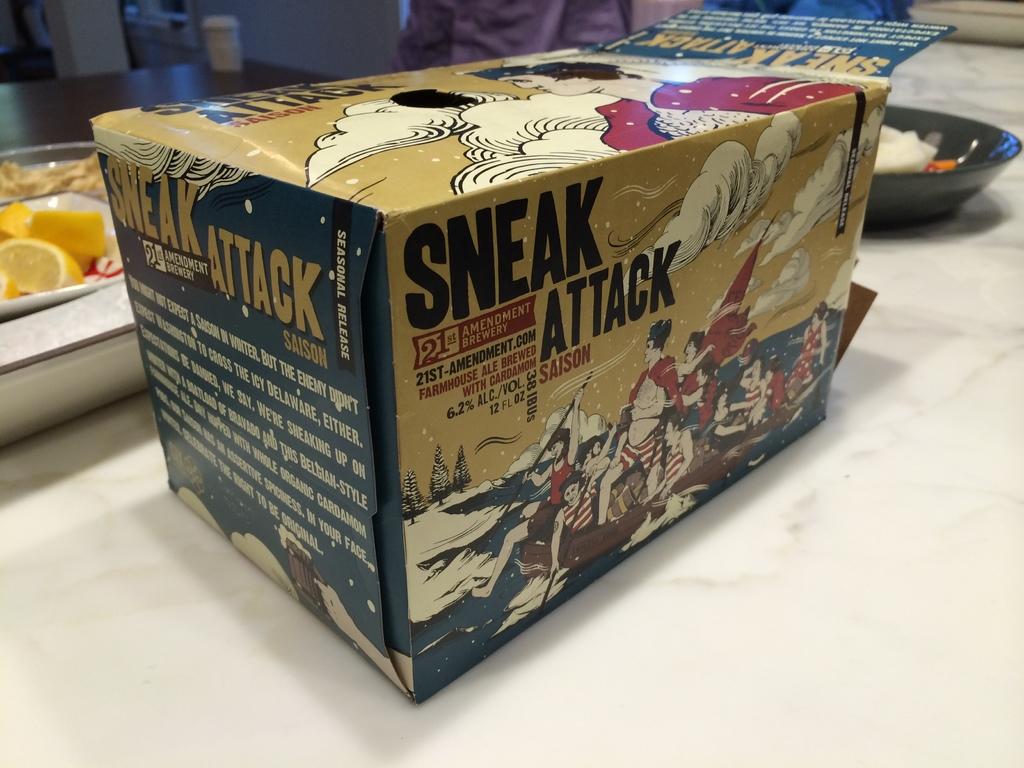What percent alcohol is this beverage?
Your answer should be very brief. 6.2%. What kind of attack does it say?
Give a very brief answer. Sneak. 